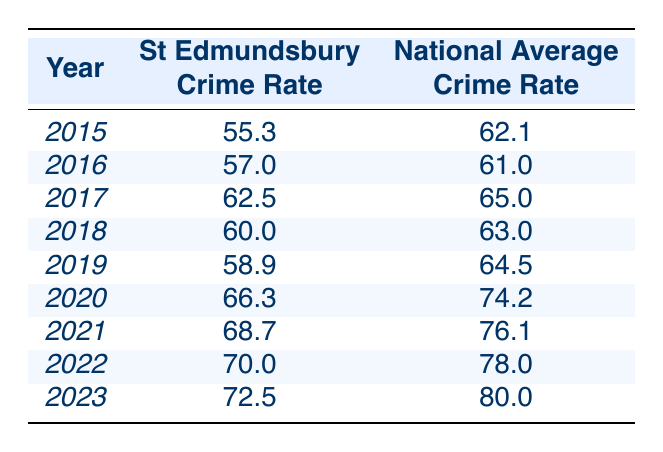What was the crime rate in St Edmundsbury in 2019? The crime rate in St Edmundsbury for 2019 is found in the table, and it shows a value of 58.9.
Answer: 58.9 How does the St Edmundsbury crime rate in 2021 compare to the national average for that same year? In 2021, the St Edmundsbury crime rate is 68.7, while the national average is 76.1. This shows that St Edmundsbury's crime rate was lower than the national average by 7.4.
Answer: Lower by 7.4 What is the difference between the St Edmundsbury crime rate in 2020 and that in 2022? The crime rate in St Edmundsbury for 2020 is 66.3, and for 2022 it is 70.0. The difference is calculated as 70.0 - 66.3, which equals 3.7.
Answer: 3.7 What was the national average crime rate in 2015? Looking at the table, the national average crime rate in 2015 is 62.1.
Answer: 62.1 Was the St Edmundsbury crime rate higher or lower than the national average in 2018? In 2018, St Edmundsbury had a crime rate of 60.0, while the national average was 63.0. Therefore, St Edmundsbury's rate was lower than the national average.
Answer: Lower How has the crime rate in St Edmundsbury changed from 2015 to 2023? In 2015, the crime rate was 55.3, rising to 72.5 in 2023. The increase is calculated as 72.5 - 55.3 = 17.2. Therefore, the rate increased by 17.2 over this period.
Answer: Increased by 17.2 What was the average crime rate in St Edmundsbury from 2015 to 2023? To find the average, add the crime rates from each year (55.3 + 57.0 + 62.5 + 60.0 + 58.9 + 66.3 + 68.7 + 70.0 + 72.5) =  419.2. Then divide by the 9 years: 419.2 / 9 ≈ 46.577, which rounds to 65.5.
Answer: 65.5 What trends can be observed in the St Edmundsbury crime rates over the years? The data shows an overall increasing trend in crime rates from 55.3 in 2015 to 72.5 in 2023, with fluctuations. The overall increase indicates a general rise in crime.
Answer: Increasing trend Did St Edmundsbury's crime rate exceed the national average crime rate in 2022? In 2022, the St Edmundsbury crime rate was 70.0, while the national average was 78.0. Therefore, St Edmundsbury did not exceed the national average.
Answer: No What was the highest recorded crime rate in St Edmundsbury from 2015 to 2023? The highest crime rate for St Edmundsbury is 72.5 in 2023, as indicated in the table.
Answer: 72.5 What was the percentage increase in St Edmundsbury's crime rate from 2020 to 2023? The crime rate in 2020 was 66.3 and in 2023 it was 72.5. The increase is 72.5 - 66.3 = 6.2. To find the percentage, use the formula (6.2 / 66.3) * 100 ≈ 9.34%.
Answer: Approximately 9.34% 